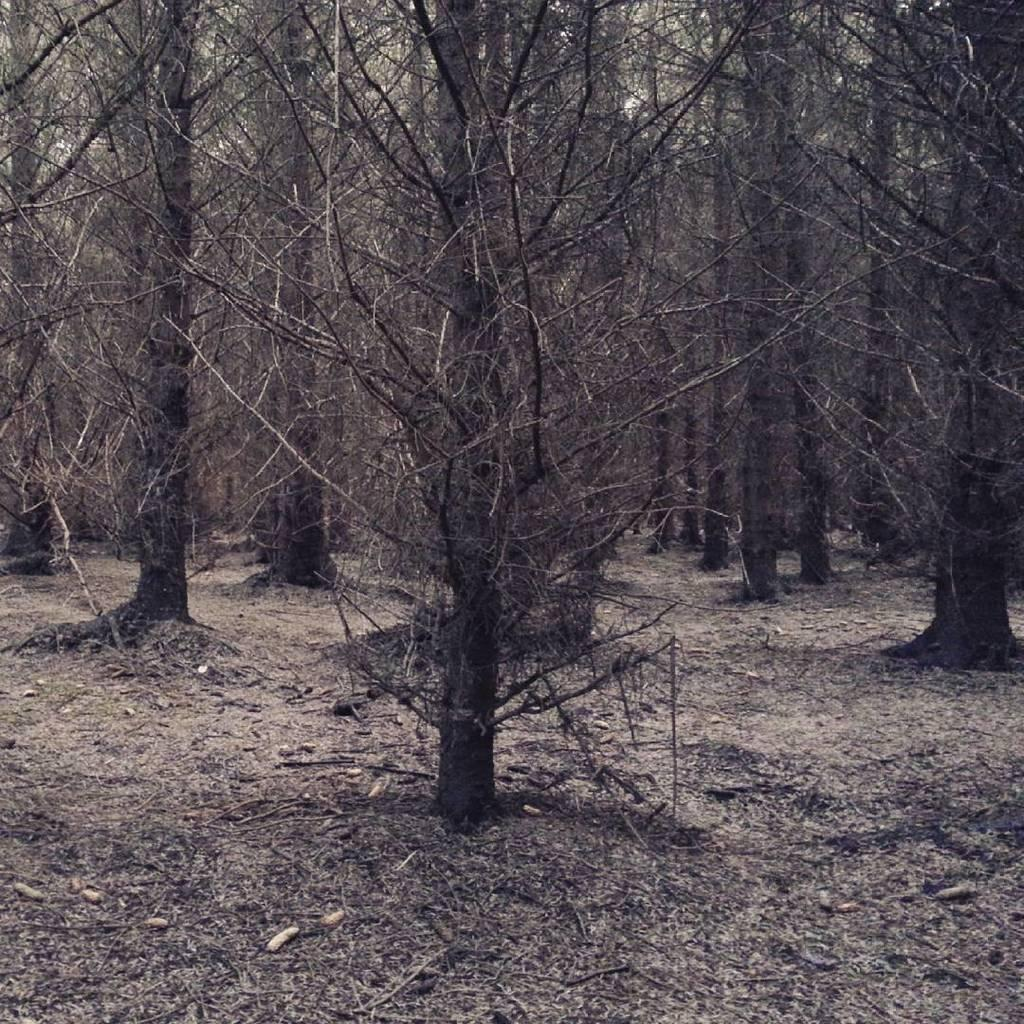Where was the image taken? The image was taken in a forest. What can be seen in the forest in the image? There are trees with branches in the image. How much honey is being collected by the bees in the image? There are no bees or honey visible in the image; it only features trees with branches in a forest setting. 